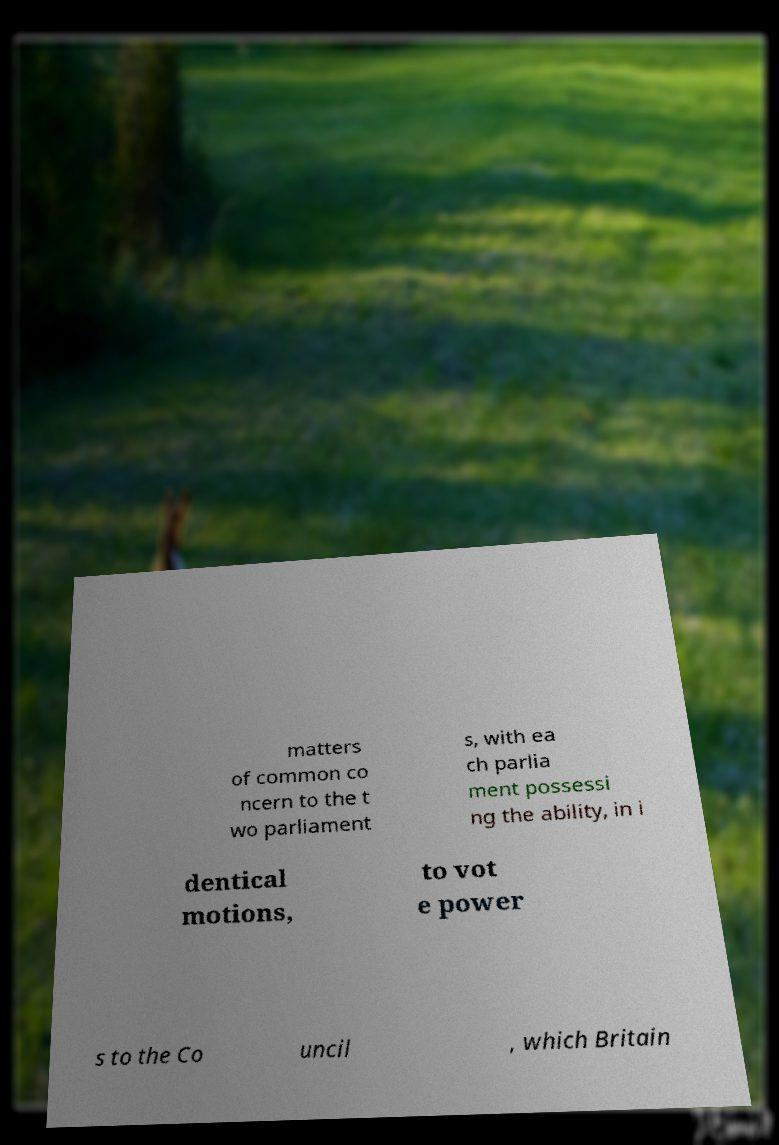Could you assist in decoding the text presented in this image and type it out clearly? matters of common co ncern to the t wo parliament s, with ea ch parlia ment possessi ng the ability, in i dentical motions, to vot e power s to the Co uncil , which Britain 